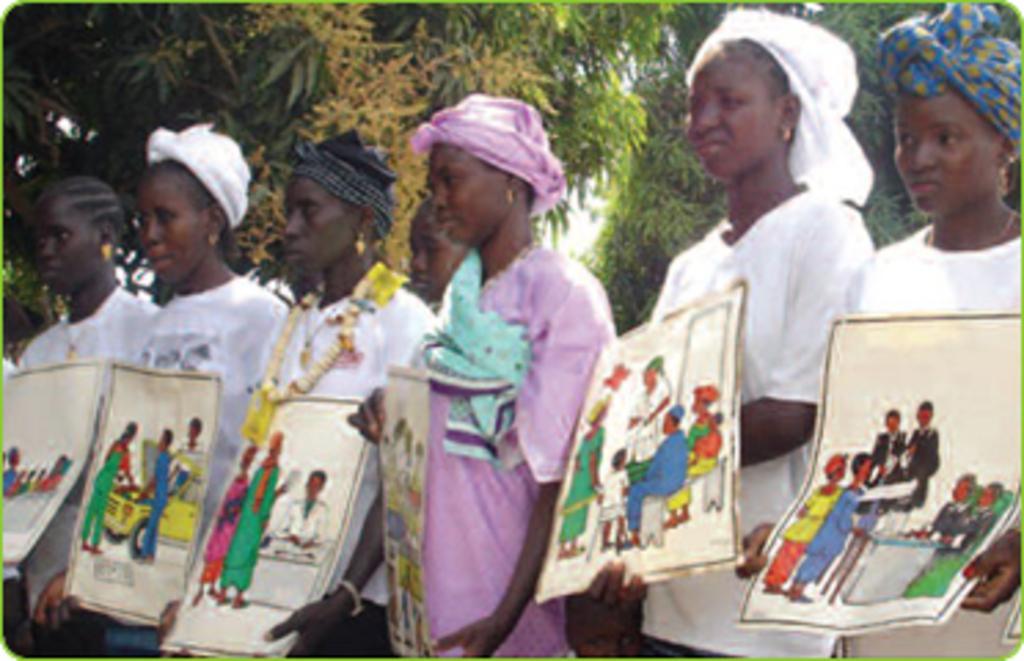Could you give a brief overview of what you see in this image? In this image there are a few people standing and holding some papers with some paintings in it. In the background there are trees. 